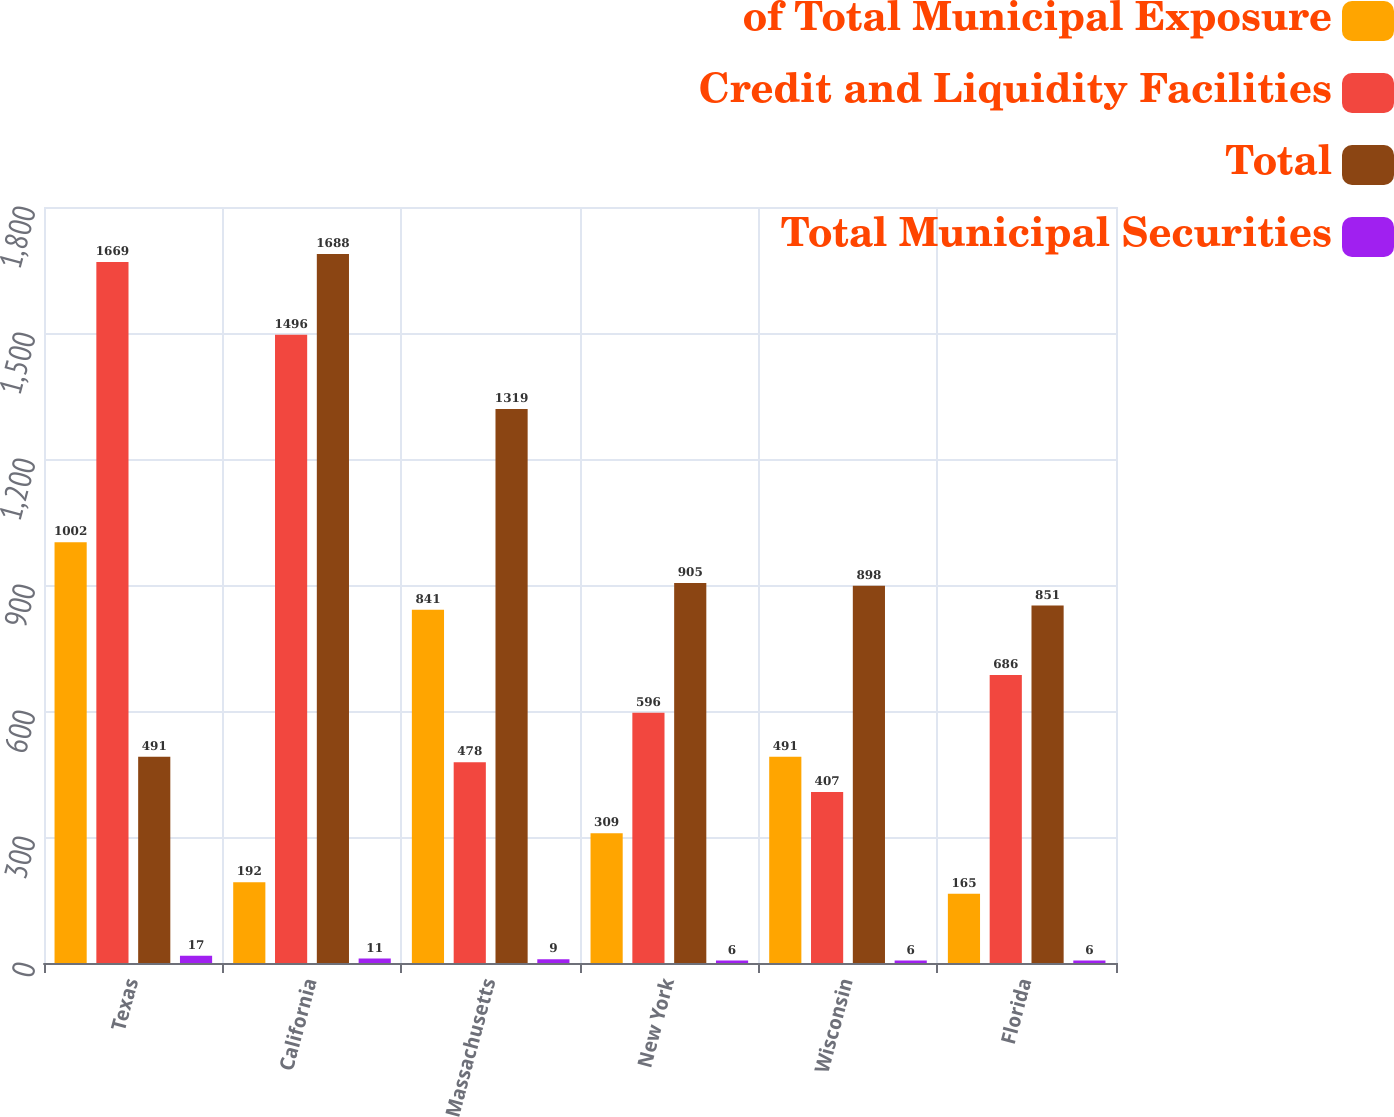<chart> <loc_0><loc_0><loc_500><loc_500><stacked_bar_chart><ecel><fcel>Texas<fcel>California<fcel>Massachusetts<fcel>New York<fcel>Wisconsin<fcel>Florida<nl><fcel>of Total Municipal Exposure<fcel>1002<fcel>192<fcel>841<fcel>309<fcel>491<fcel>165<nl><fcel>Credit and Liquidity Facilities<fcel>1669<fcel>1496<fcel>478<fcel>596<fcel>407<fcel>686<nl><fcel>Total<fcel>491<fcel>1688<fcel>1319<fcel>905<fcel>898<fcel>851<nl><fcel>Total Municipal Securities<fcel>17<fcel>11<fcel>9<fcel>6<fcel>6<fcel>6<nl></chart> 